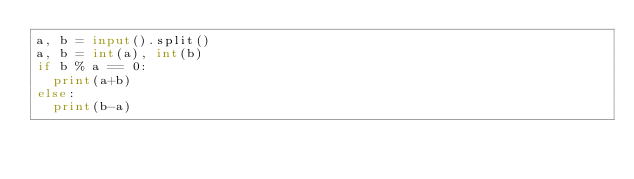<code> <loc_0><loc_0><loc_500><loc_500><_Python_>a, b = input().split()
a, b = int(a), int(b)
if b % a == 0:
  print(a+b)
else:
  print(b-a)</code> 